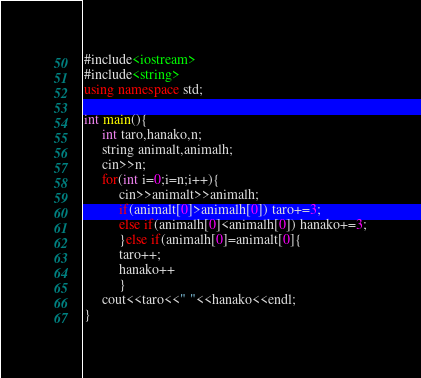Convert code to text. <code><loc_0><loc_0><loc_500><loc_500><_C++_>#include<iostream>
#include<string>
using namespace std;

int main(){
     int taro,hanako,n;
     string animalt,animalh;
     cin>>n;
     for(int i=0;i=n;i++){
          cin>>animalt>>animalh;
          if(animalt[0]>animalh[0]) taro+=3;
          else if(animalh[0]<animalh[0]) hanako+=3;
          }else if(animalh[0]=animalt[0]{
          taro++;
          hanako++
          }
     cout<<taro<<" "<<hanako<<endl;
}</code> 